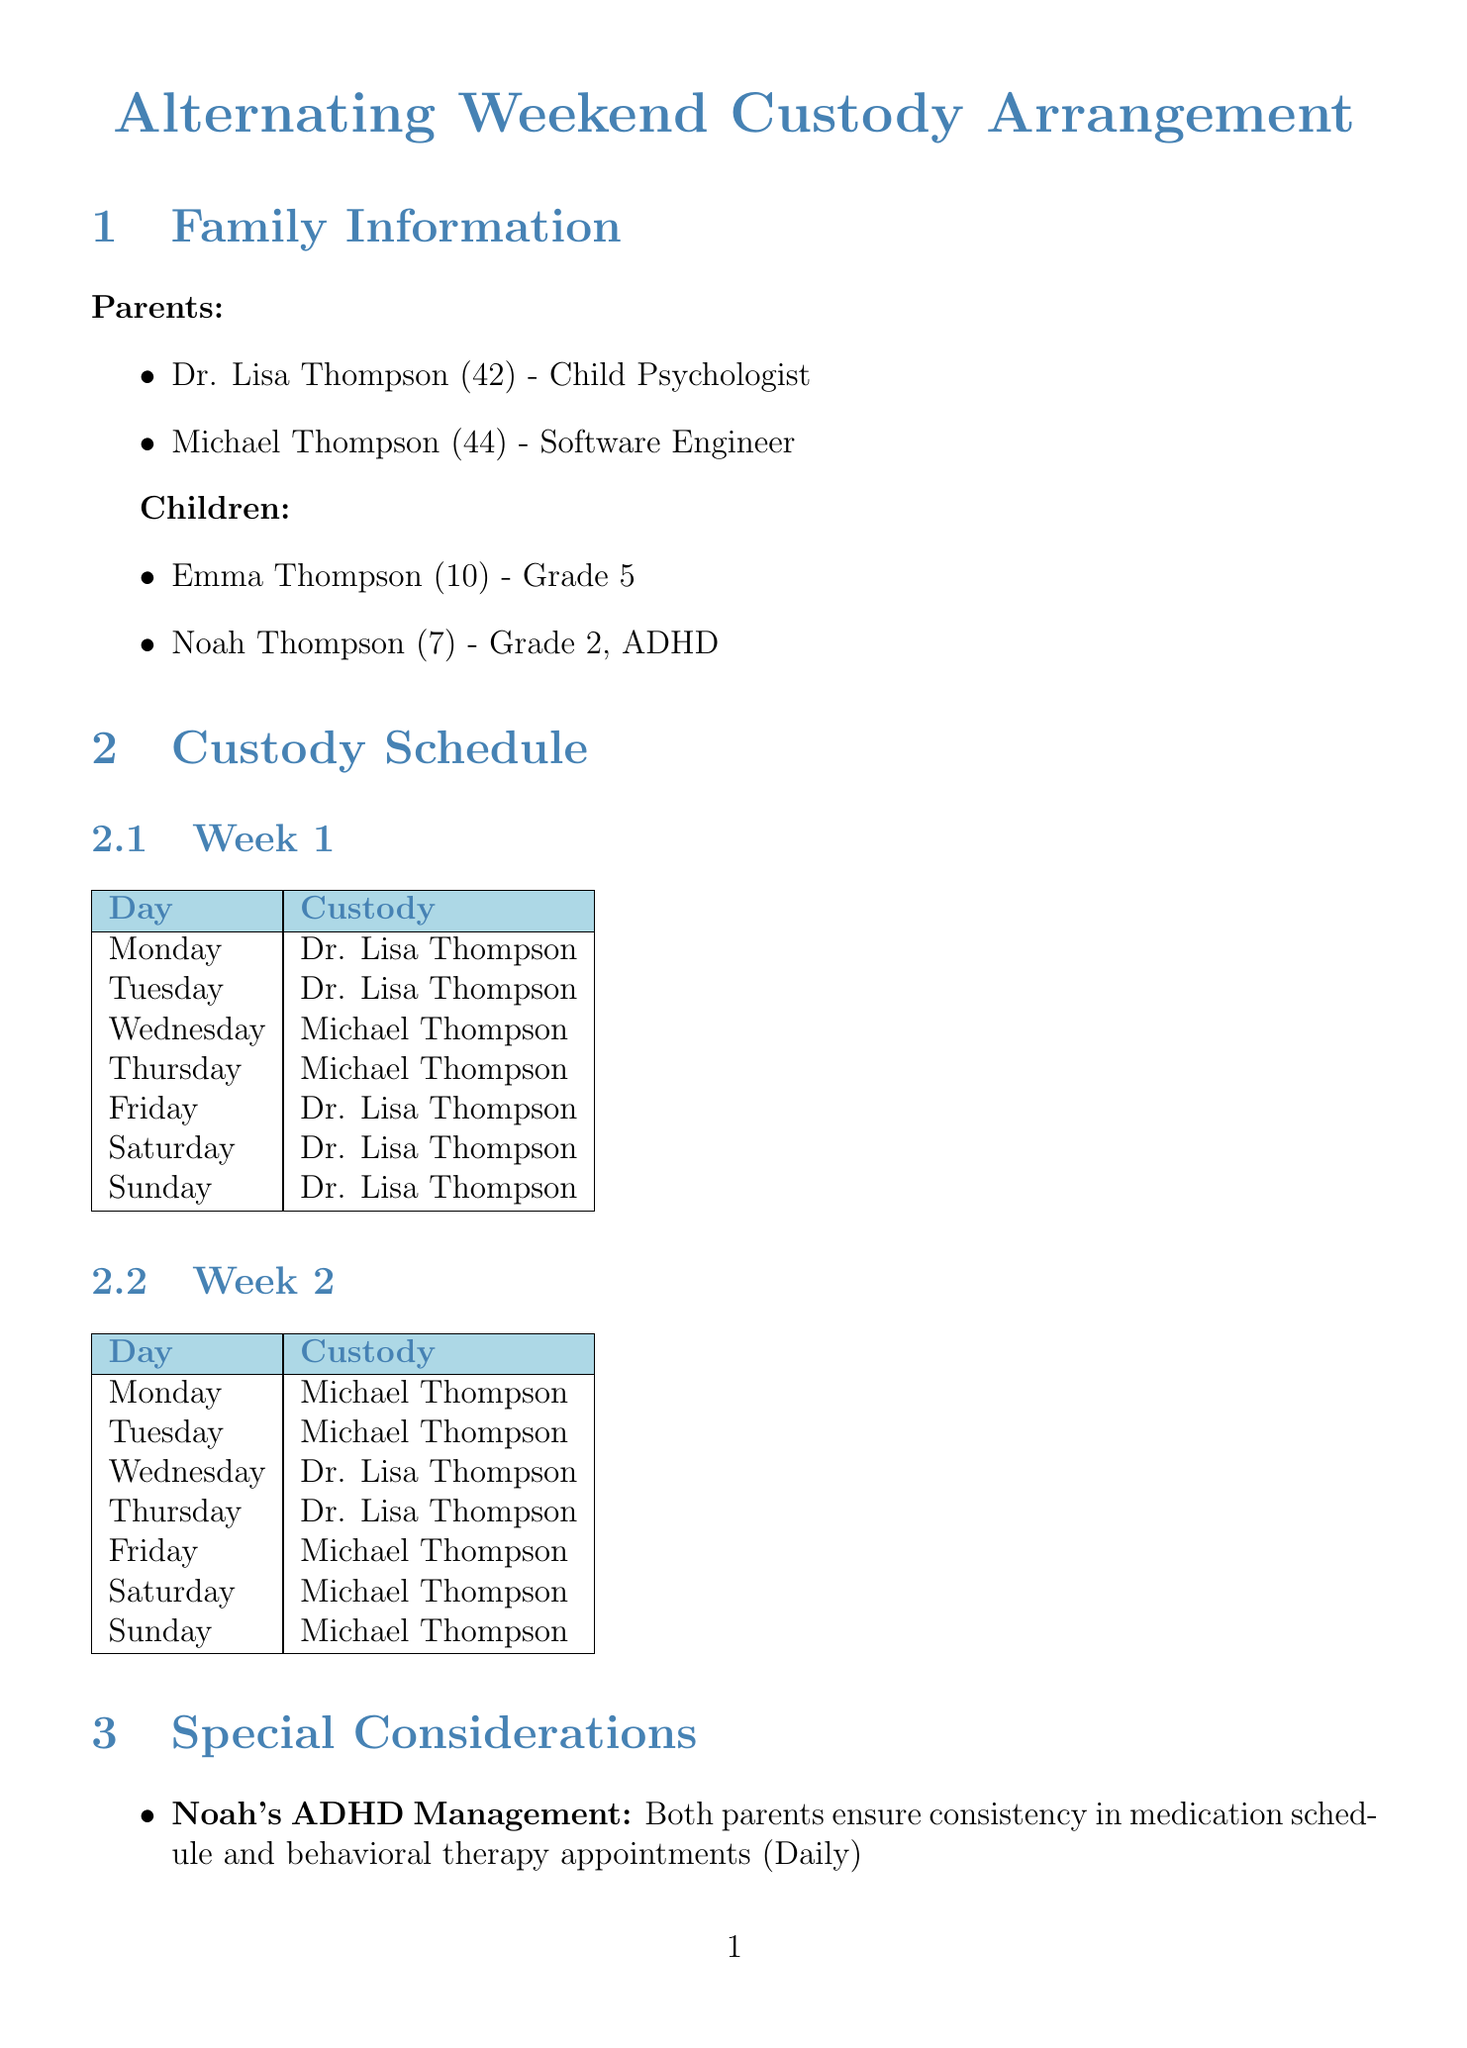What is the age of Emma Thompson? Emma Thompson is listed as being 10 years old in the document.
Answer: 10 Who is responsible for Noah's ADHD management? The document states that both parents are responsible for Noah's ADHD management.
Answer: Both parents What day does Emma have her piano lessons? The document specifies that Emma's piano lessons occur every Tuesday at 4 PM.
Answer: Every Tuesday at 4 PM Which parent has custody of the children on Fridays during Week 1? According to the custody schedule for Week 1, Dr. Lisa Thompson has custody on Fridays.
Answer: Dr. Lisa Thompson Which holiday does Michael Thompson have in odd years? The document notes that Michael Thompson has custody of the children during Thanksgiving in odd years.
Answer: Thanksgiving What is the communication method used by the parents? The communication plan states that the parents use a co-parenting app called OurFamilyWizard.
Answer: OurFamilyWizard How often are family therapy sessions scheduled? The document mentions that family therapy sessions are scheduled bi-weekly on Saturdays at 10 AM.
Answer: Bi-weekly on Saturdays at 10 AM What is the frequency of updates on the children's activities? The document states that updates on the children's activities occur daily.
Answer: Daily 